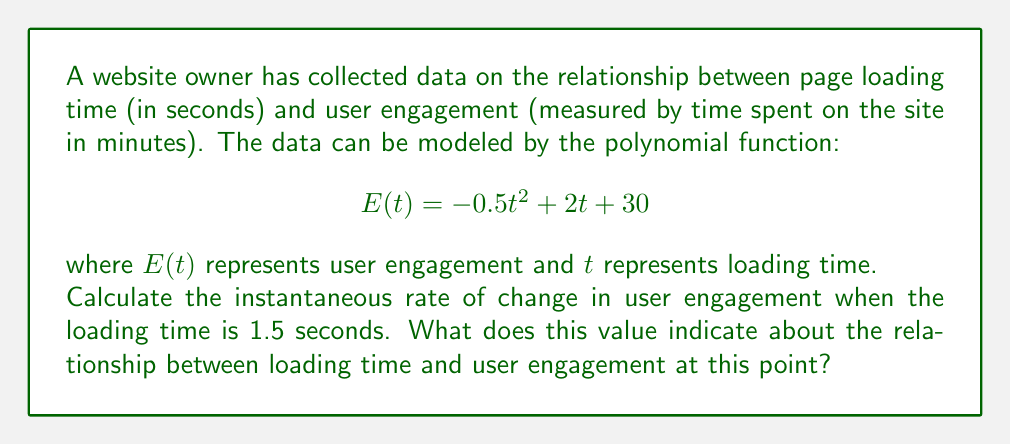What is the answer to this math problem? To solve this problem, we need to find the derivative of the function $E(t)$ and evaluate it at $t = 1.5$. This will give us the instantaneous rate of change.

1. First, let's find the derivative of $E(t)$:
   $$E(t) = -0.5t^2 + 2t + 30$$
   $$E'(t) = -t + 2$$

2. Now, we evaluate $E'(t)$ at $t = 1.5$:
   $$E'(1.5) = -(1.5) + 2 = -1.5 + 2 = 0.5$$

3. Interpreting the result:
   The rate of change at $t = 1.5$ is 0.5 minutes per second. This means that when the loading time is 1.5 seconds, for each additional second of loading time, the user engagement is increasing by 0.5 minutes (or 30 seconds).

4. However, it's important to note that this is the instantaneous rate of change at exactly 1.5 seconds. The negative coefficient of $t^2$ in the original function indicates that this rate of change will eventually become negative as loading time increases further, showing a decrease in user engagement for longer loading times.
Answer: The instantaneous rate of change in user engagement when the loading time is 1.5 seconds is 0.5 minutes per second. This indicates that at this specific loading time, user engagement is still increasing with respect to loading time, but the rate of increase will start to slow down and eventually decrease for longer loading times. 